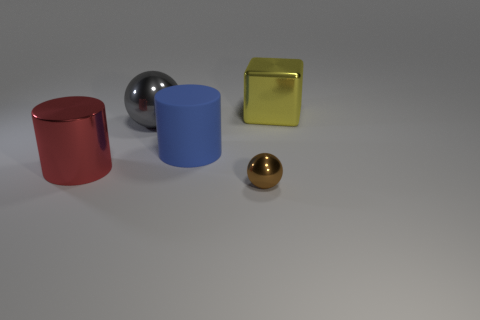Is there any other thing that is the same size as the brown sphere?
Offer a terse response. No. There is a object in front of the metallic cylinder; what shape is it?
Offer a terse response. Sphere. Is the shape of the big red object the same as the large blue rubber thing?
Give a very brief answer. Yes. Are there the same number of large shiny things left of the tiny brown metal sphere and cylinders?
Give a very brief answer. Yes. There is a small brown shiny object; what shape is it?
Provide a short and direct response. Sphere. Is there any other thing of the same color as the large ball?
Keep it short and to the point. No. There is a ball that is behind the large blue cylinder; does it have the same size as the sphere in front of the large matte object?
Make the answer very short. No. What shape is the large object in front of the large cylinder that is behind the shiny cylinder?
Your response must be concise. Cylinder. Is the size of the red shiny cylinder the same as the metal sphere in front of the large ball?
Provide a short and direct response. No. There is a sphere in front of the sphere that is to the left of the ball that is in front of the blue matte cylinder; what size is it?
Give a very brief answer. Small. 